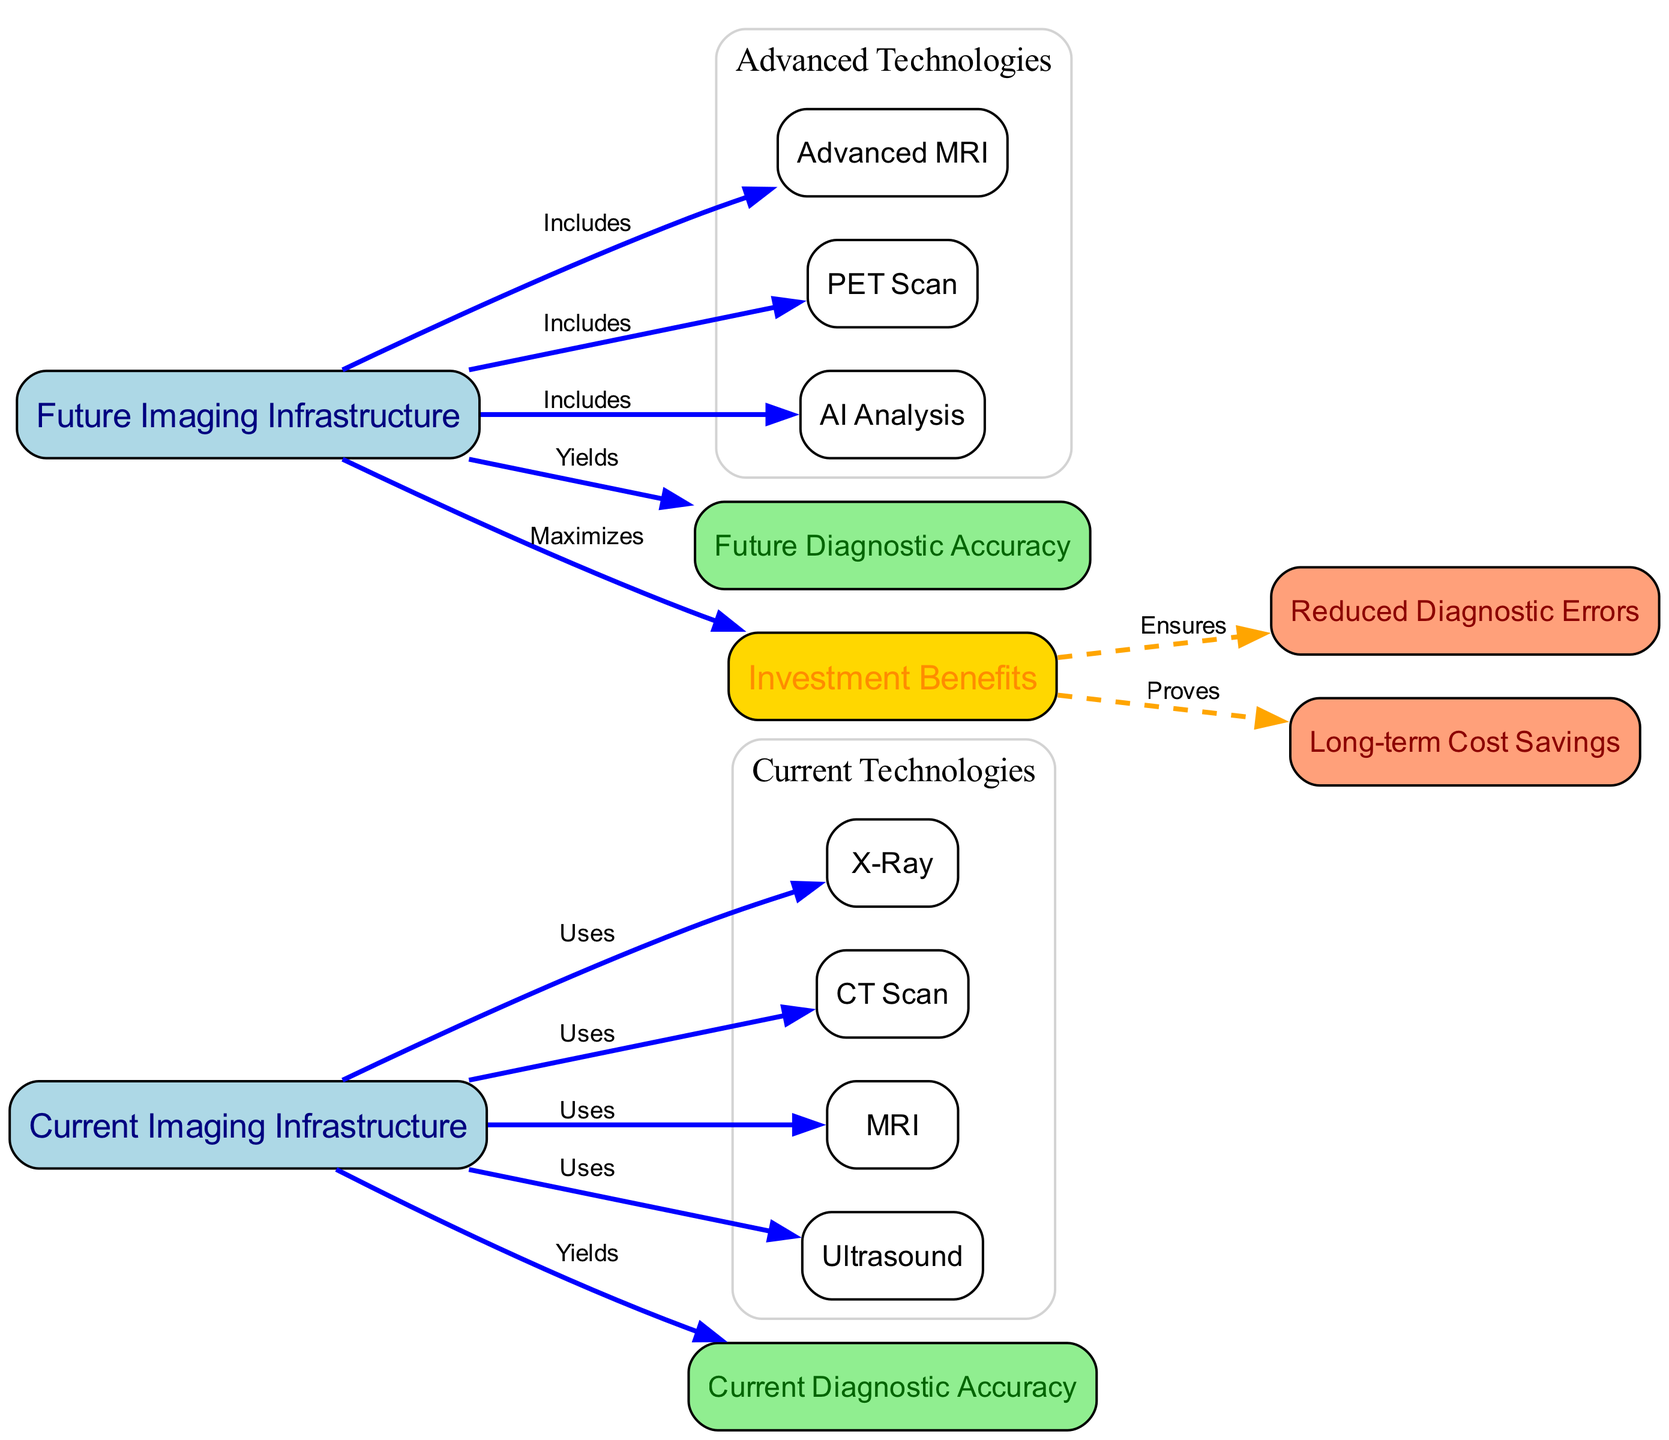What technologies are currently used in diagnostic imaging? The diagram shows four technologies associated with the "Current Imaging Infrastructure": X-Ray, CT Scan, MRI, and Ultrasound.
Answer: X-Ray, CT Scan, MRI, Ultrasound What is the future diagnostic accuracy labeled in the diagram? The "Future Diagnostic Accuracy" is indicated as a node in the diagram that is associated with the "Future Imaging Infrastructure." The actual value is not provided but it is named accordingly in the diagram.
Answer: Future Diagnostic Accuracy How many nodes represent the current imaging infrastructure technologies? The diagram specifies four nodes under "Current Imaging Infrastructure" which are X-Ray, CT Scan, MRI, and Ultrasound. Therefore, the count is based on these listed nodes.
Answer: 4 What is assured by investment benefits in the diagram? The investment benefits node connects to two nodes: "Reduced Diagnostic Errors" and "Long-term Cost Savings," indicating what is guaranteed through investment in advanced imaging infrastructure.
Answer: Reduced Diagnostic Errors, Long-term Cost Savings Which advanced technology is included in the future imaging infrastructure that involves AI? The "AI Analysis" node is specifically listed under the "Future Imaging Infrastructure," indicating its inclusion.
Answer: AI Analysis How does future infrastructure maximize benefits compared to current infrastructure? The "Future Imaging Infrastructure" node connects to "Investment Benefits," suggesting that it maximizes the benefits that can be derived from the advanced technologies and methodologies implemented.
Answer: Investment Benefits What relationship exists between current infrastructure and diagnostic accuracy? The diagram shows a direct relationship where "Current Imaging Infrastructure" yields "Current Diagnostic Accuracy," showing the output derived from current technologies.
Answer: Yields What advanced imaging technology is associated with PET scans in the future infrastructure? The future imaging infrastructure node indicates "PET Scan" as one of the advanced technologies included for better diagnostics.
Answer: PET Scan 